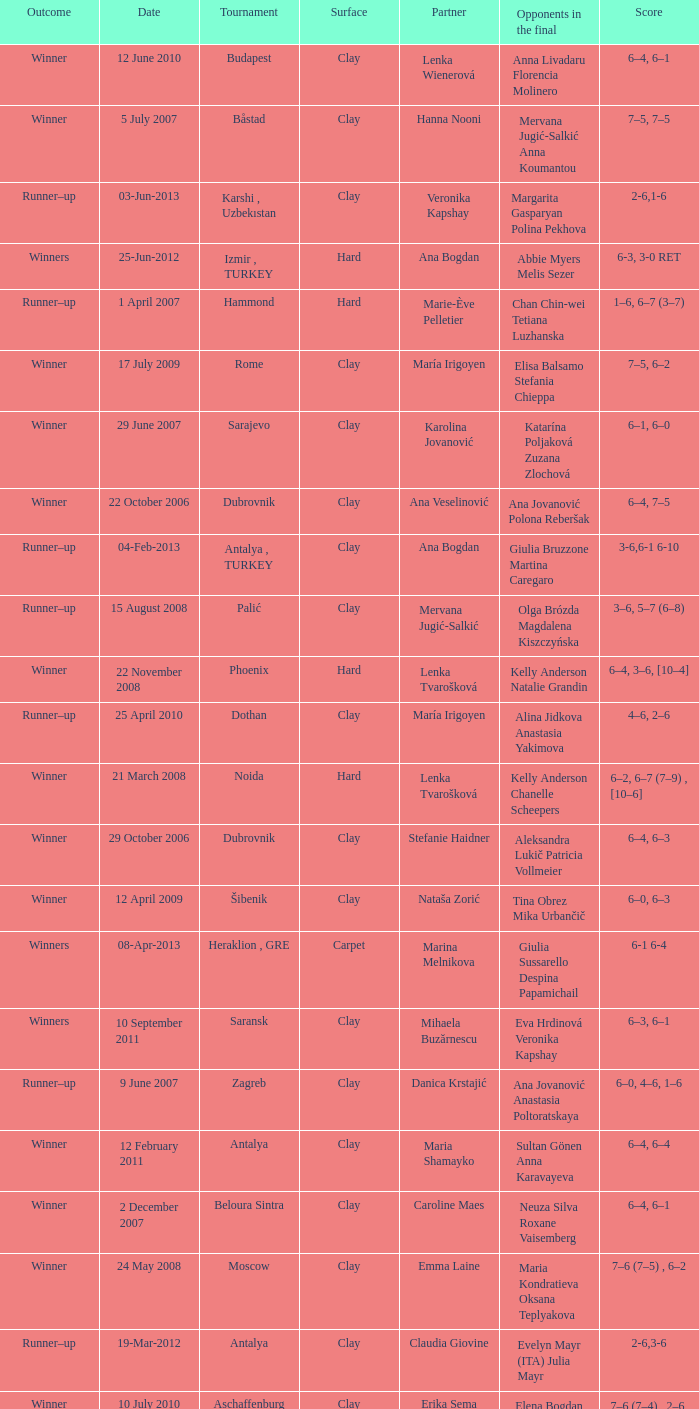Who were the opponents in the final at Noida? Kelly Anderson Chanelle Scheepers. 